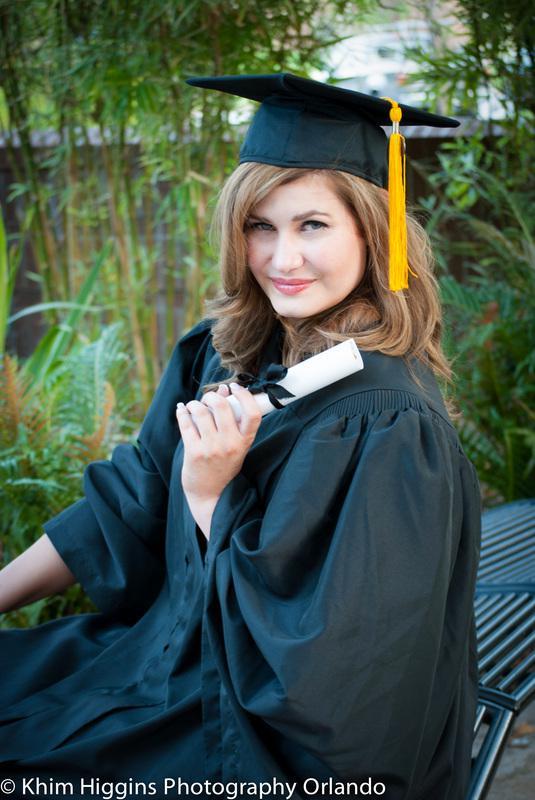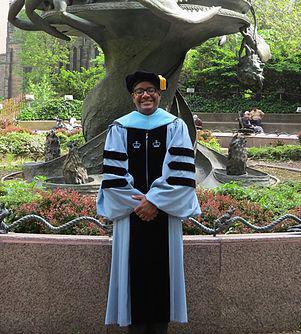The first image is the image on the left, the second image is the image on the right. Analyze the images presented: Is the assertion "And at least one image there is a single female with long white hair holding a rolled up white diploma while still dressed in her cap and gown." valid? Answer yes or no. No. The first image is the image on the left, the second image is the image on the right. Given the left and right images, does the statement "There is exactly one person in cap and gown in the right image." hold true? Answer yes or no. Yes. 